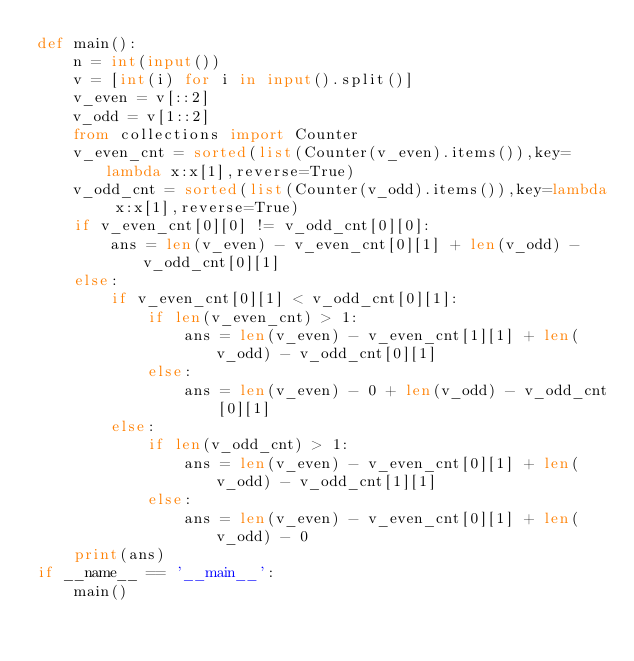Convert code to text. <code><loc_0><loc_0><loc_500><loc_500><_Python_>def main():
    n = int(input())
    v = [int(i) for i in input().split()]
    v_even = v[::2]
    v_odd = v[1::2]
    from collections import Counter
    v_even_cnt = sorted(list(Counter(v_even).items()),key=lambda x:x[1],reverse=True)
    v_odd_cnt = sorted(list(Counter(v_odd).items()),key=lambda x:x[1],reverse=True)
    if v_even_cnt[0][0] != v_odd_cnt[0][0]:
        ans = len(v_even) - v_even_cnt[0][1] + len(v_odd) - v_odd_cnt[0][1]
    else:
        if v_even_cnt[0][1] < v_odd_cnt[0][1]:
            if len(v_even_cnt) > 1:
                ans = len(v_even) - v_even_cnt[1][1] + len(v_odd) - v_odd_cnt[0][1]
            else:
                ans = len(v_even) - 0 + len(v_odd) - v_odd_cnt[0][1]
        else:
            if len(v_odd_cnt) > 1:
                ans = len(v_even) - v_even_cnt[0][1] + len(v_odd) - v_odd_cnt[1][1]
            else:
                ans = len(v_even) - v_even_cnt[0][1] + len(v_odd) - 0
    print(ans)
if __name__ == '__main__':
    main()</code> 